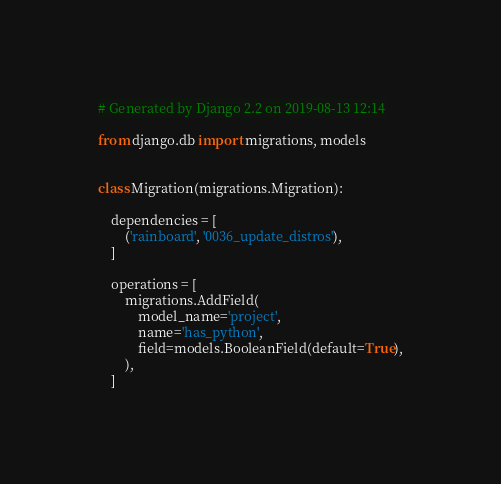Convert code to text. <code><loc_0><loc_0><loc_500><loc_500><_Python_># Generated by Django 2.2 on 2019-08-13 12:14

from django.db import migrations, models


class Migration(migrations.Migration):

    dependencies = [
        ('rainboard', '0036_update_distros'),
    ]

    operations = [
        migrations.AddField(
            model_name='project',
            name='has_python',
            field=models.BooleanField(default=True),
        ),
    ]
</code> 